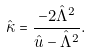Convert formula to latex. <formula><loc_0><loc_0><loc_500><loc_500>\hat { \kappa } = \frac { - 2 \hat { \Lambda } ^ { 2 } } { \hat { u } - \hat { \Lambda } ^ { 2 } } .</formula> 